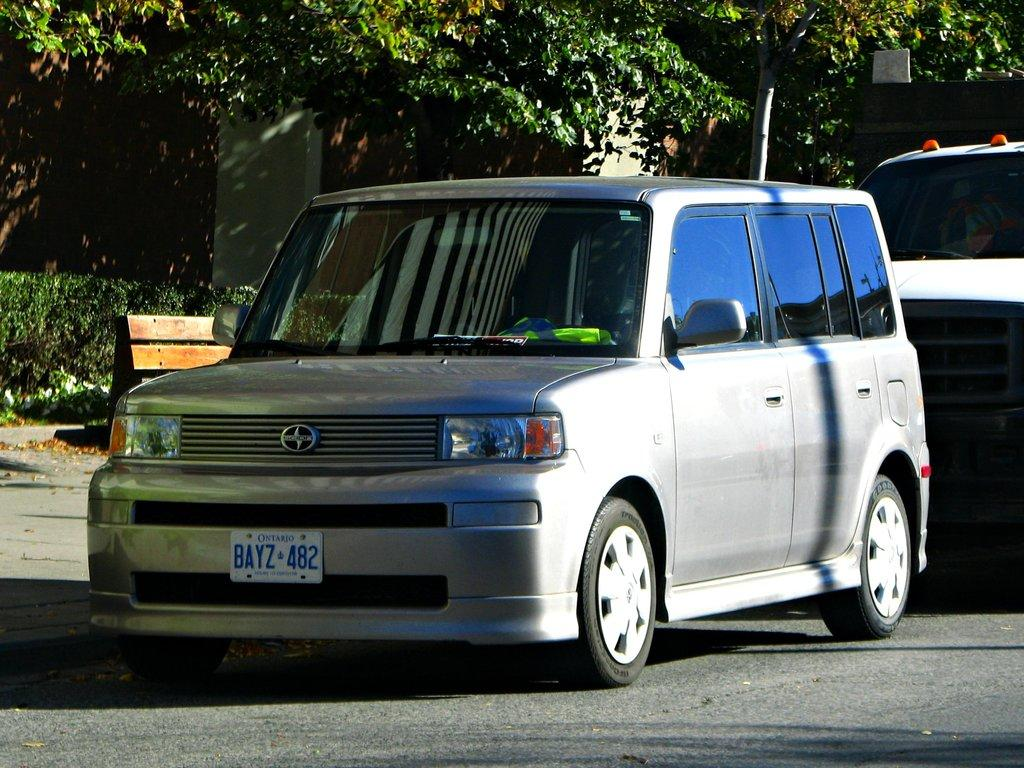How many cars are visible in the image? There are two cars in the image. What can be seen in the background of the image? There are trees and a house in the background of the image. What is located on the left side of the image? There is a bench and shrubs on the left side of the image. What type of event is taking place in the image? There is no indication of an event taking place in the image. 